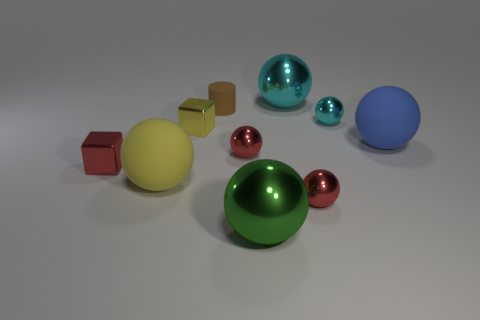Are there any blue objects that have the same size as the yellow rubber object?
Give a very brief answer. Yes. What is the material of the cyan sphere that is the same size as the yellow ball?
Give a very brief answer. Metal. There is a green object; is its size the same as the matte sphere to the right of the green metal sphere?
Give a very brief answer. Yes. What number of metallic objects are either big blue objects or cubes?
Provide a succinct answer. 2. How many yellow matte objects are the same shape as the tiny cyan object?
Provide a short and direct response. 1. Do the red shiny ball behind the small red block and the cyan thing in front of the brown matte cylinder have the same size?
Your answer should be compact. Yes. There is a red shiny thing that is left of the tiny brown cylinder; what is its shape?
Give a very brief answer. Cube. There is a blue object that is the same shape as the yellow matte object; what is it made of?
Your answer should be compact. Rubber. Is the size of the red sphere behind the yellow rubber object the same as the tiny yellow shiny thing?
Your answer should be very brief. Yes. How many large cyan balls are in front of the big yellow thing?
Offer a terse response. 0. 